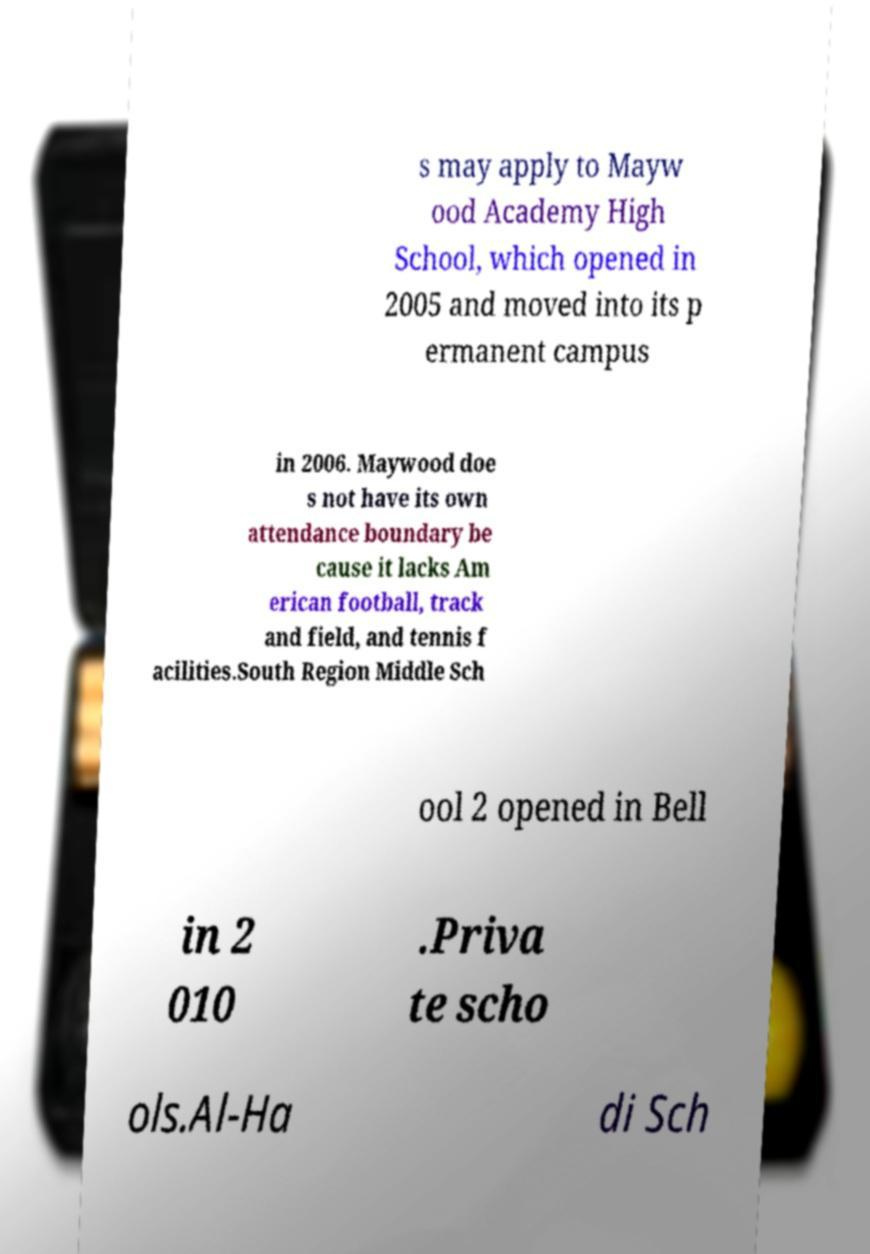Can you accurately transcribe the text from the provided image for me? s may apply to Mayw ood Academy High School, which opened in 2005 and moved into its p ermanent campus in 2006. Maywood doe s not have its own attendance boundary be cause it lacks Am erican football, track and field, and tennis f acilities.South Region Middle Sch ool 2 opened in Bell in 2 010 .Priva te scho ols.Al-Ha di Sch 